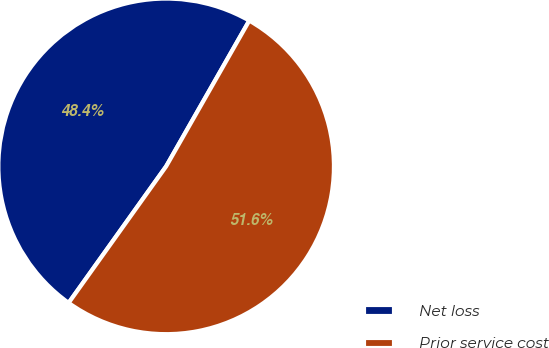Convert chart. <chart><loc_0><loc_0><loc_500><loc_500><pie_chart><fcel>Net loss<fcel>Prior service cost<nl><fcel>48.38%<fcel>51.62%<nl></chart> 